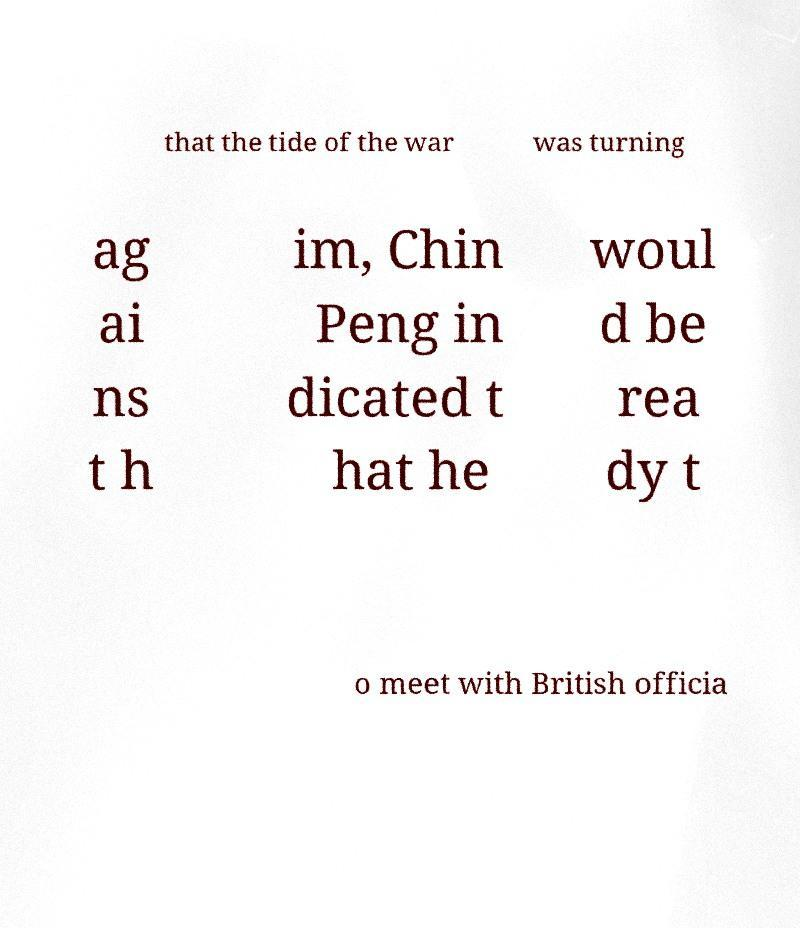Could you assist in decoding the text presented in this image and type it out clearly? that the tide of the war was turning ag ai ns t h im, Chin Peng in dicated t hat he woul d be rea dy t o meet with British officia 